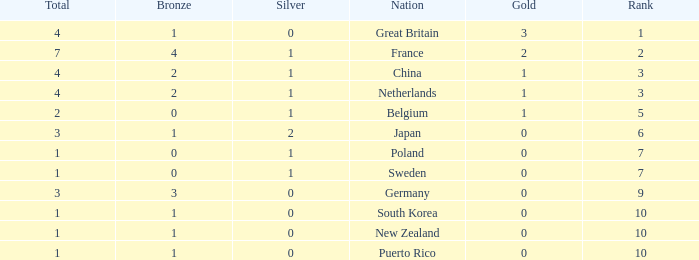What is the total where the gold is larger than 2? 1.0. 